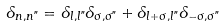Convert formula to latex. <formula><loc_0><loc_0><loc_500><loc_500>\delta _ { n , n " } = \delta _ { l , l " } \delta _ { \sigma , \sigma " } + \delta _ { l + \sigma , l " } \delta _ { - \sigma , \sigma " }</formula> 